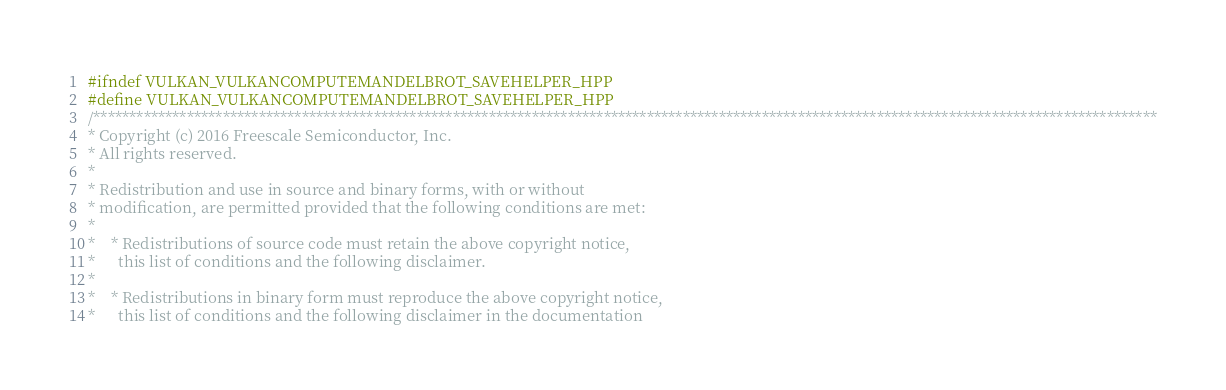Convert code to text. <code><loc_0><loc_0><loc_500><loc_500><_C++_>#ifndef VULKAN_VULKANCOMPUTEMANDELBROT_SAVEHELPER_HPP
#define VULKAN_VULKANCOMPUTEMANDELBROT_SAVEHELPER_HPP
/****************************************************************************************************************************************************
* Copyright (c) 2016 Freescale Semiconductor, Inc.
* All rights reserved.
*
* Redistribution and use in source and binary forms, with or without
* modification, are permitted provided that the following conditions are met:
*
*    * Redistributions of source code must retain the above copyright notice,
*      this list of conditions and the following disclaimer.
*
*    * Redistributions in binary form must reproduce the above copyright notice,
*      this list of conditions and the following disclaimer in the documentation</code> 